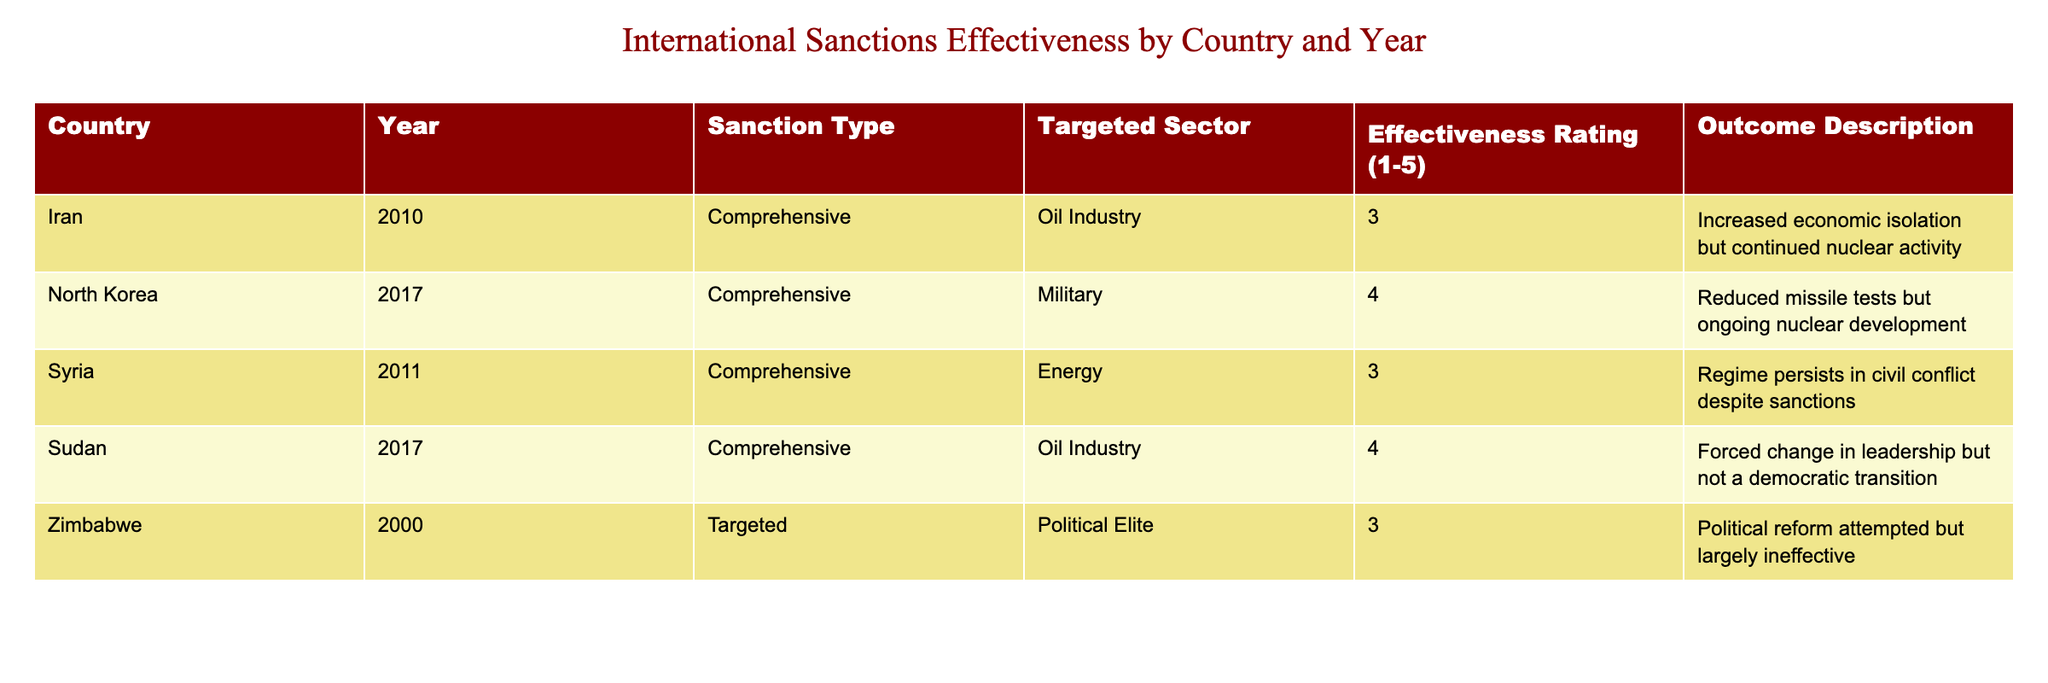What country received sanctions in the year 2017? In the table, I can scan the "Year" column for the year 2017. The countries listed with sanctions during that year are North Korea and Sudan.
Answer: North Korea and Sudan Which targeted sector received sanctions in Iran according to the table? I can find Iran in the "Country" column and look at the corresponding "Targeted Sector" for that row, which shows the oil industry.
Answer: Oil Industry What is the effectiveness rating of the comprehensive sanctions on Syria? By looking for Syria in the "Country" column and checking the "Effectiveness Rating," I find that Syria has a rating of 3 for its comprehensive sanctions.
Answer: 3 Is there any country with an effectiveness rating of 4 in the table? I can check each row to see if any rows include an effectiveness rating of 4. By reviewing the data, I see that North Korea and Sudan both have a rating of 4.
Answer: Yes Calculate the average effectiveness rating for all the countries listed in the table. To find the average, I sum up all the effectiveness ratings: 3 (Iran) + 4 (North Korea) + 3 (Syria) + 4 (Sudan) + 3 (Zimbabwe) = 17. There are 5 ratings, so the average is 17/5 = 3.4.
Answer: 3.4 Which country showed a forced change in leadership but not a democratic transition? I review the "Outcome Description" for each country and find that the description for Sudan matches this criteria.
Answer: Sudan Do comprehensive sanctions tend to have a higher effectiveness rating than targeted sanctions in the table? In the table, maximum effectiveness ratings for comprehensive sanctions are 4 (North Korea, Sudan) while the highest for targeted sanctions is 3 (Zimbabwe), showing comprehensive sanctions are generally more effective.
Answer: Yes What outcome did Syria experience despite the sanctions? By reviewing the "Outcome Description" for Syria, it indicates that the regime persists in civil conflict, despite sanctions.
Answer: Regime persists in civil conflict 